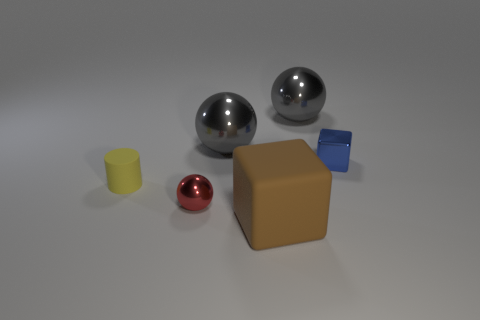Subtract all large metal spheres. How many spheres are left? 1 Subtract all red spheres. How many spheres are left? 2 Add 3 balls. How many objects exist? 9 Subtract all blue cylinders. How many gray balls are left? 2 Subtract all cylinders. How many objects are left? 5 Subtract all purple cylinders. Subtract all blue cubes. How many cylinders are left? 1 Subtract all small blue objects. Subtract all brown matte blocks. How many objects are left? 4 Add 2 big brown matte objects. How many big brown matte objects are left? 3 Add 5 tiny blocks. How many tiny blocks exist? 6 Subtract 1 red balls. How many objects are left? 5 